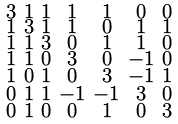Convert formula to latex. <formula><loc_0><loc_0><loc_500><loc_500>\begin{smallmatrix} 3 & 1 & 1 & 1 & 1 & 0 & 0 \\ 1 & 3 & 1 & 1 & 0 & 1 & 1 \\ 1 & 1 & 3 & 0 & 1 & 1 & 0 \\ 1 & 1 & 0 & 3 & 0 & - 1 & 0 \\ 1 & 0 & 1 & 0 & 3 & - 1 & 1 \\ 0 & 1 & 1 & - 1 & - 1 & 3 & 0 \\ 0 & 1 & 0 & 0 & 1 & 0 & 3 \end{smallmatrix}</formula> 